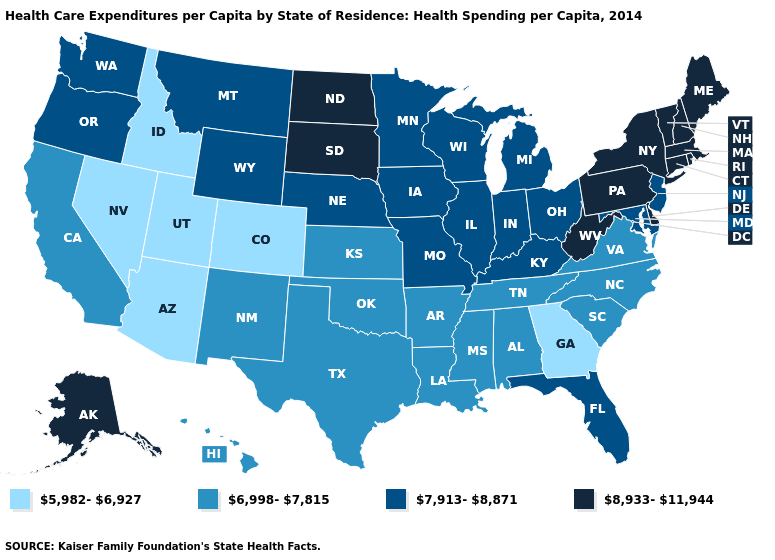Does Missouri have a higher value than Maine?
Short answer required. No. Name the states that have a value in the range 8,933-11,944?
Keep it brief. Alaska, Connecticut, Delaware, Maine, Massachusetts, New Hampshire, New York, North Dakota, Pennsylvania, Rhode Island, South Dakota, Vermont, West Virginia. What is the value of Colorado?
Concise answer only. 5,982-6,927. Is the legend a continuous bar?
Write a very short answer. No. How many symbols are there in the legend?
Answer briefly. 4. Name the states that have a value in the range 8,933-11,944?
Short answer required. Alaska, Connecticut, Delaware, Maine, Massachusetts, New Hampshire, New York, North Dakota, Pennsylvania, Rhode Island, South Dakota, Vermont, West Virginia. Does Maine have the lowest value in the Northeast?
Short answer required. No. Name the states that have a value in the range 5,982-6,927?
Write a very short answer. Arizona, Colorado, Georgia, Idaho, Nevada, Utah. Does Alabama have the same value as Minnesota?
Give a very brief answer. No. Name the states that have a value in the range 8,933-11,944?
Quick response, please. Alaska, Connecticut, Delaware, Maine, Massachusetts, New Hampshire, New York, North Dakota, Pennsylvania, Rhode Island, South Dakota, Vermont, West Virginia. What is the lowest value in states that border Rhode Island?
Write a very short answer. 8,933-11,944. What is the highest value in the USA?
Be succinct. 8,933-11,944. What is the value of Wyoming?
Keep it brief. 7,913-8,871. What is the value of Illinois?
Quick response, please. 7,913-8,871. What is the value of New York?
Quick response, please. 8,933-11,944. 